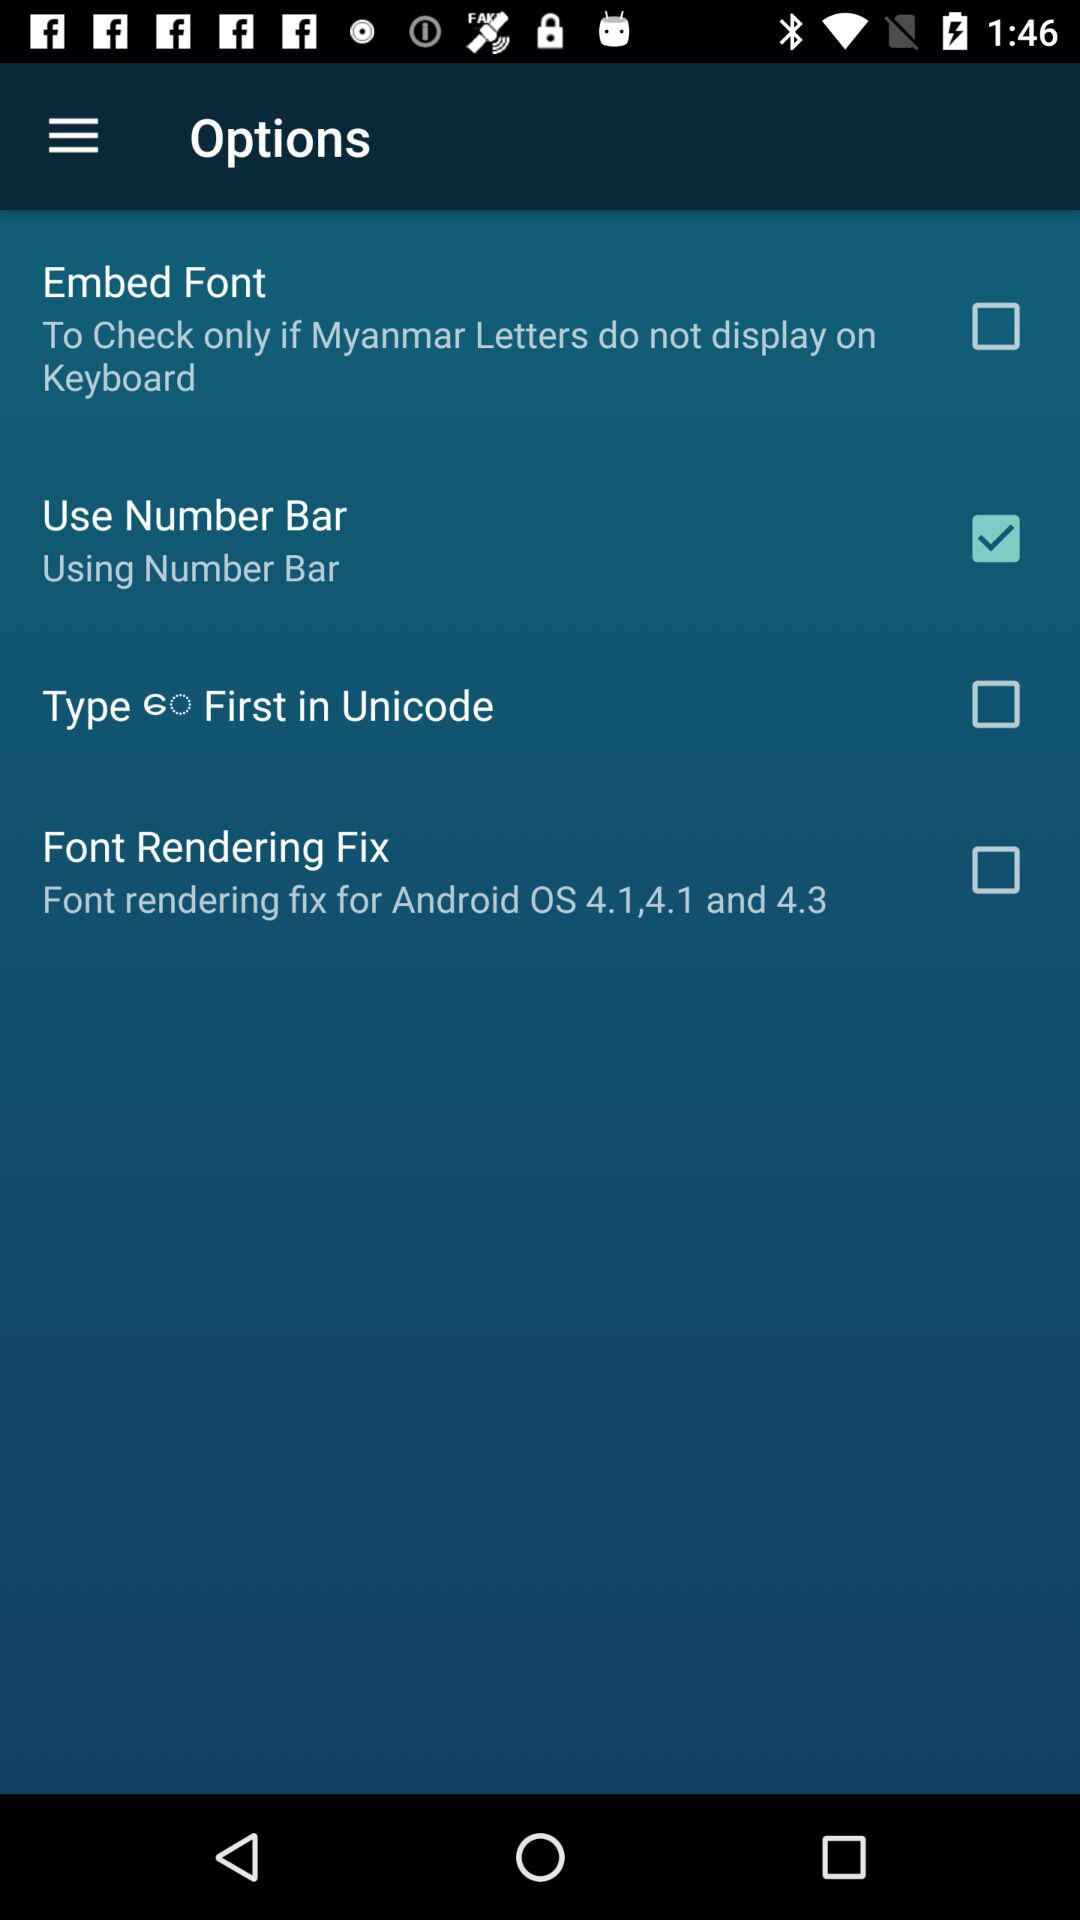What is the status of "Embed Font"? The status is "off". 